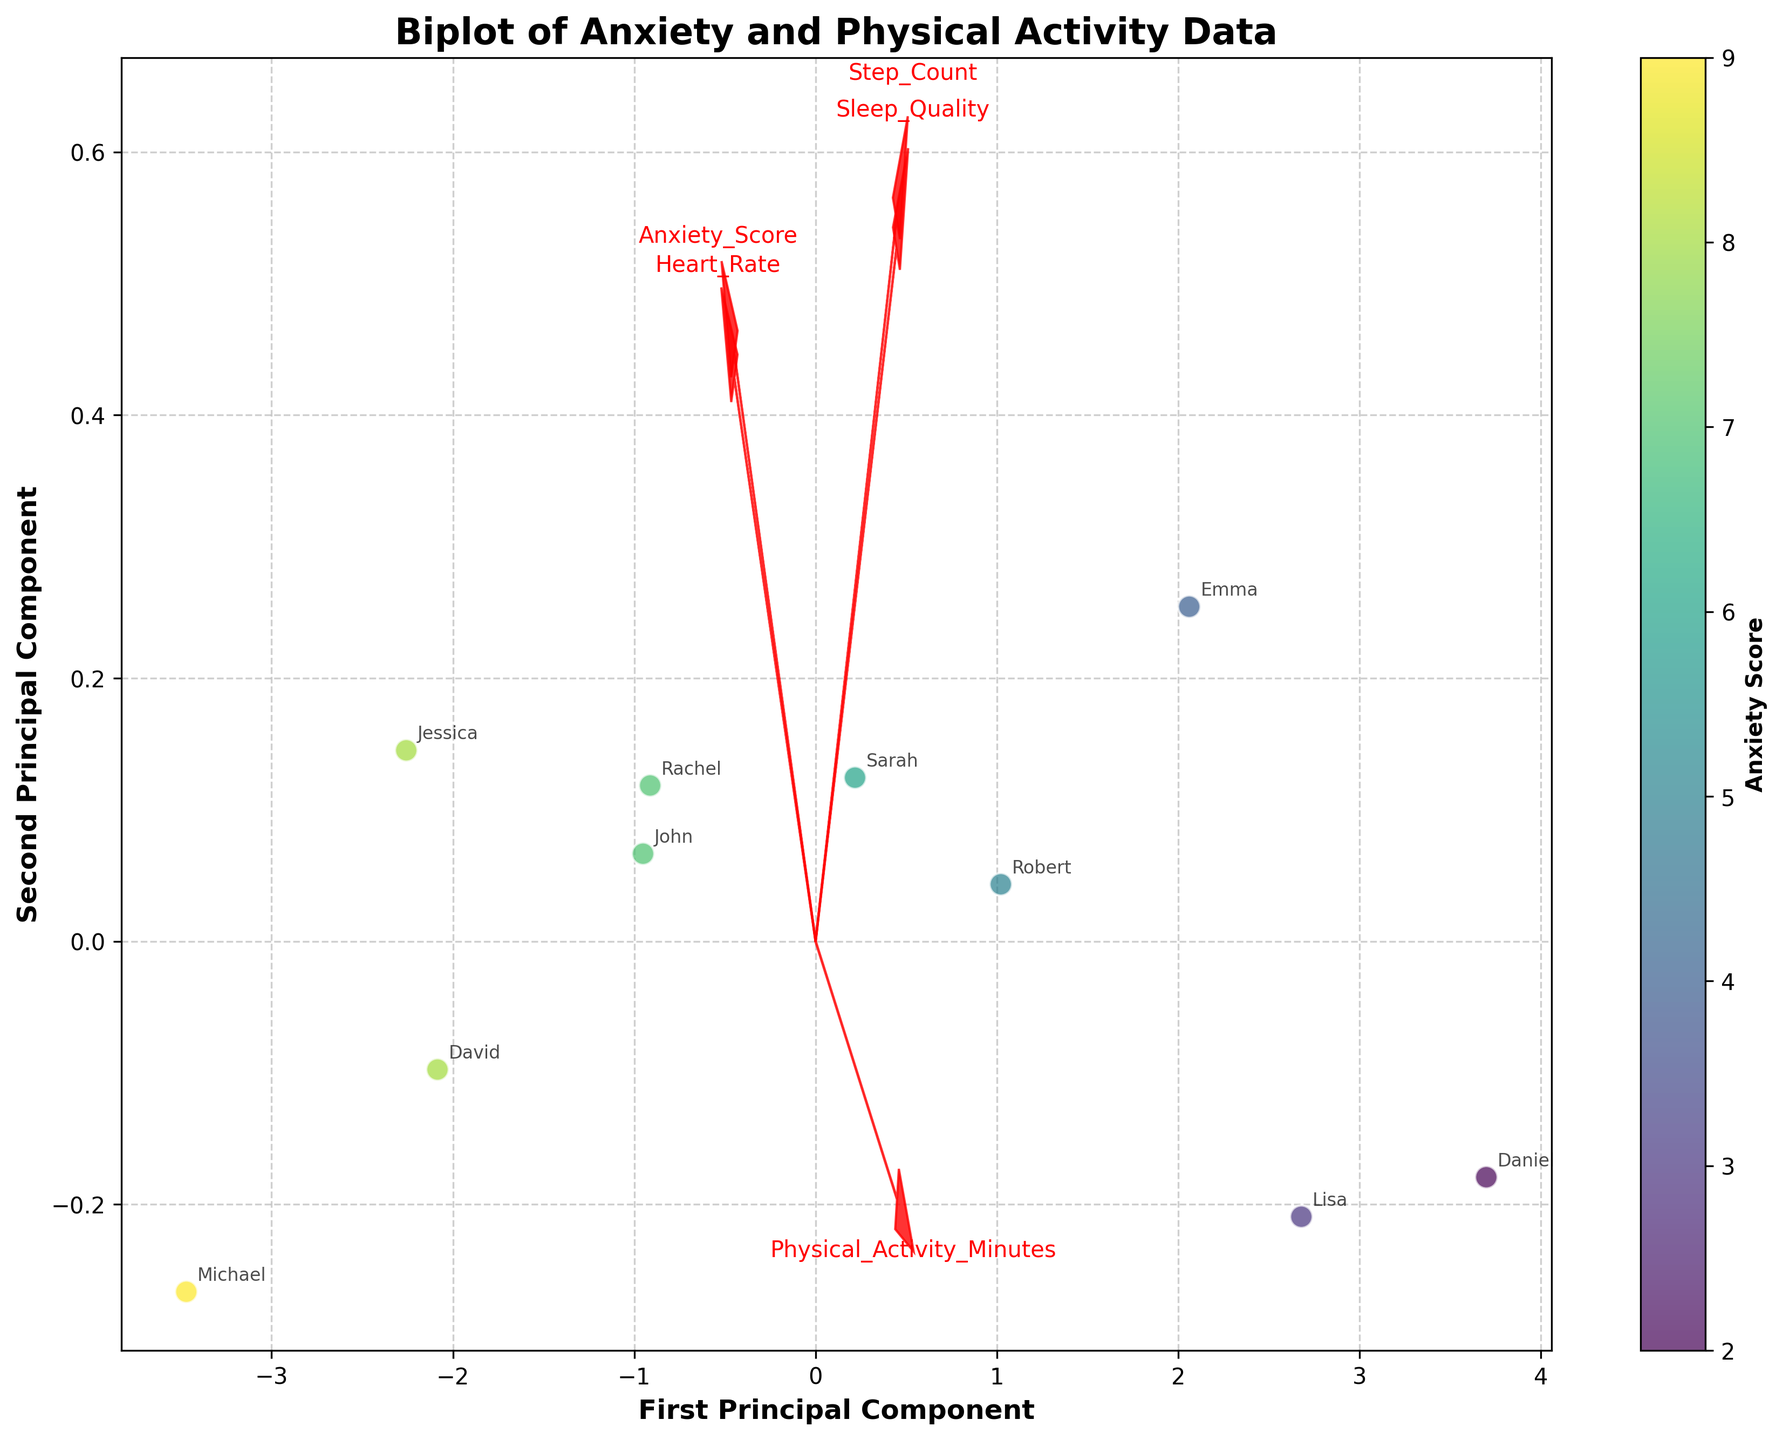What is the title of the biplot? The title is indicated prominently at the top of the figure, which helps to quickly understand the context of the plot.
Answer: Biplot of Anxiety and Physical Activity Data How many participants' data are displayed in the biplot? Each participant is represented by a point on the plot, which can be counted directly.
Answer: 10 Which variable shows the highest positive correlation with Anxiety Score based on the arrow directions? The arrow pointing in the same direction as Anxiety Score indicates a positive correlation. On reviewing the arrows representing different variables, we observe that Heart Rate seems to align most closely with Anxiety Score.
Answer: Heart Rate Which participant has the highest anxiety score according to the biplot? By observing the color intensity related to Anxiety Scores and referring to the annotations, we identify the participant with the highest Anxiety Score.
Answer: Michael Between Step Count and Sleep Quality, which is more negatively correlated with Anxiety Score? Observing the direction and length of the arrows for Step Count and Sleep Quality relative to the Anxiety Score arrow provides insight into their correlations. The Step Count vector points more in the opposite direction compared to Sleep Quality, indicating a stronger negative correlation.
Answer: Step Count What do the axes of the biplot represent? The axes represent the principal components derived from PCA, summarizing the most variance in the data. The xlabel and ylabel indicate this clearly.
Answer: First and Second Principal Components How does Physical Activity Minutes correlate with Sleep Quality in the biplot? By examining the angles and directions of the arrows for both variables, we can infer the correlation. The arrows for Physical Activity Minutes and Sleep Quality point in similar directions, suggesting a positive correlation.
Answer: Positive correlation Which two variables show the most orthogonal relationship in the biplot? Orthogonality implies no correlation, which can be observed by the vectors being perpendicular. Observing the vectors, Step Count and Heart Rate appear nearly orthogonal.
Answer: Step Count and Heart Rate Which participant annotated on the plot appears closest to the center of the biplot? By inspecting the annotations and their proximity to the plot's origin (0,0), we determine the closest one.
Answer: Robert Compare the anxiety levels of John and Daniel based on their position in the biplot. Reading the plotted points and accompanying annotations, and comparing the colors/intensity, we see John's Anxiety Score is moderate while Daniel's is considerably lower.
Answer: John has higher anxiety than Daniel 